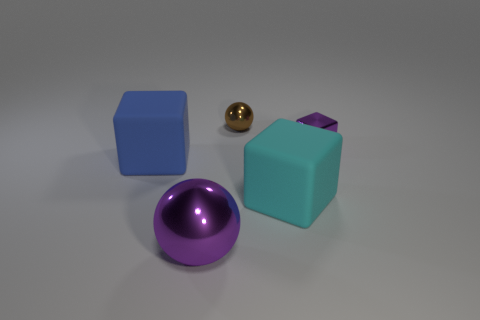There is a cyan cube; does it have the same size as the shiny sphere left of the brown shiny ball? While the cyan cube and the shiny sphere near the brown ball appear to be different in size upon closer inspection, it's challenging to determine absolute size without direct comparison. The cyan cube is likely larger given its apparent dimensions and the perspective of the image. 